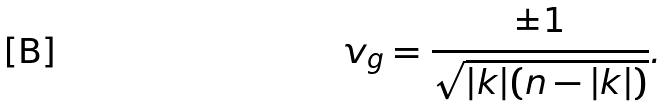<formula> <loc_0><loc_0><loc_500><loc_500>v _ { g } = \frac { \pm 1 } { \sqrt { | k | ( n - | k | ) } } .</formula> 